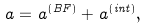Convert formula to latex. <formula><loc_0><loc_0><loc_500><loc_500>a = a ^ { \left ( B F \right ) } + a ^ { \left ( i n t \right ) } ,</formula> 